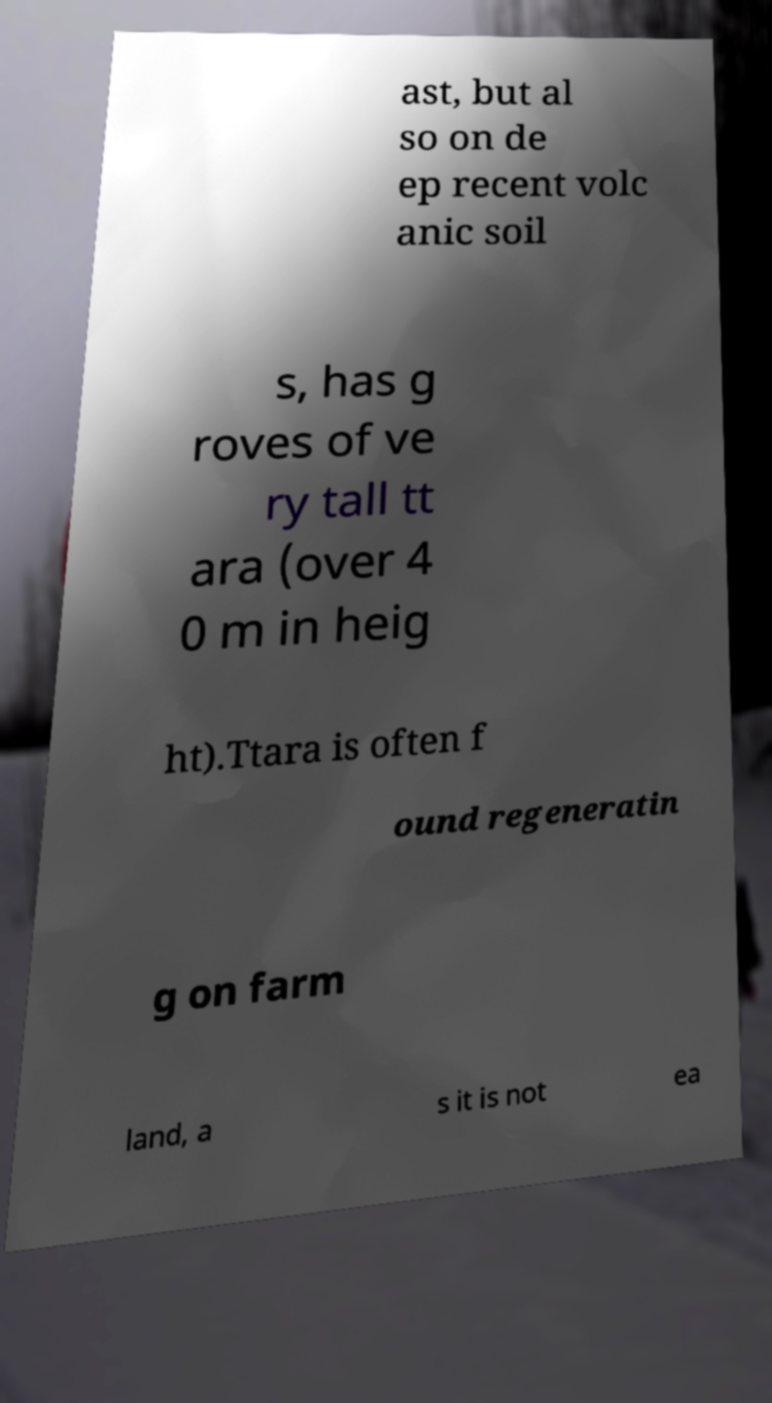Can you accurately transcribe the text from the provided image for me? ast, but al so on de ep recent volc anic soil s, has g roves of ve ry tall tt ara (over 4 0 m in heig ht).Ttara is often f ound regeneratin g on farm land, a s it is not ea 